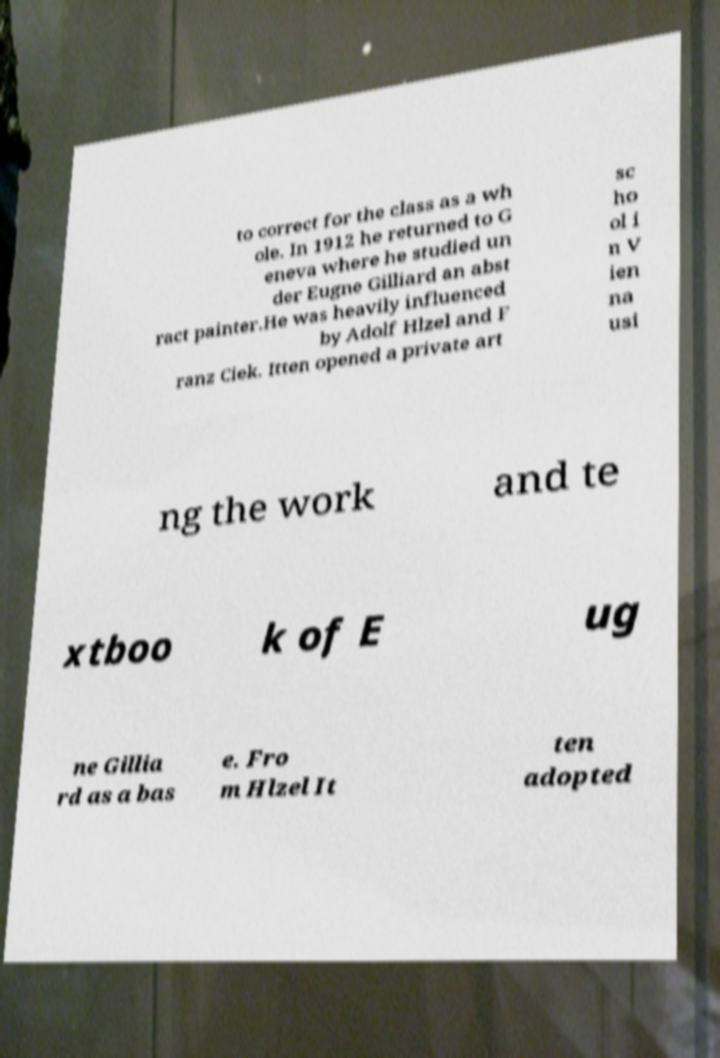Please read and relay the text visible in this image. What does it say? to correct for the class as a wh ole. In 1912 he returned to G eneva where he studied un der Eugne Gilliard an abst ract painter.He was heavily influenced by Adolf Hlzel and F ranz Ciek. Itten opened a private art sc ho ol i n V ien na usi ng the work and te xtboo k of E ug ne Gillia rd as a bas e. Fro m Hlzel It ten adopted 